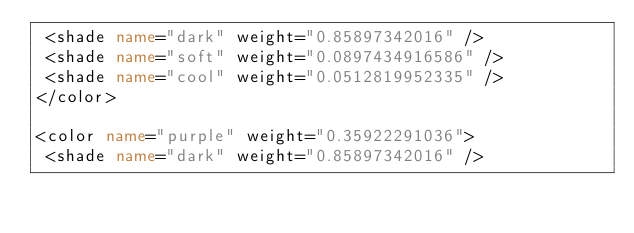<code> <loc_0><loc_0><loc_500><loc_500><_XML_> <shade name="dark" weight="0.85897342016" />
 <shade name="soft" weight="0.0897434916586" />
 <shade name="cool" weight="0.0512819952335" />
</color>

<color name="purple" weight="0.35922291036">
 <shade name="dark" weight="0.85897342016" /></code> 